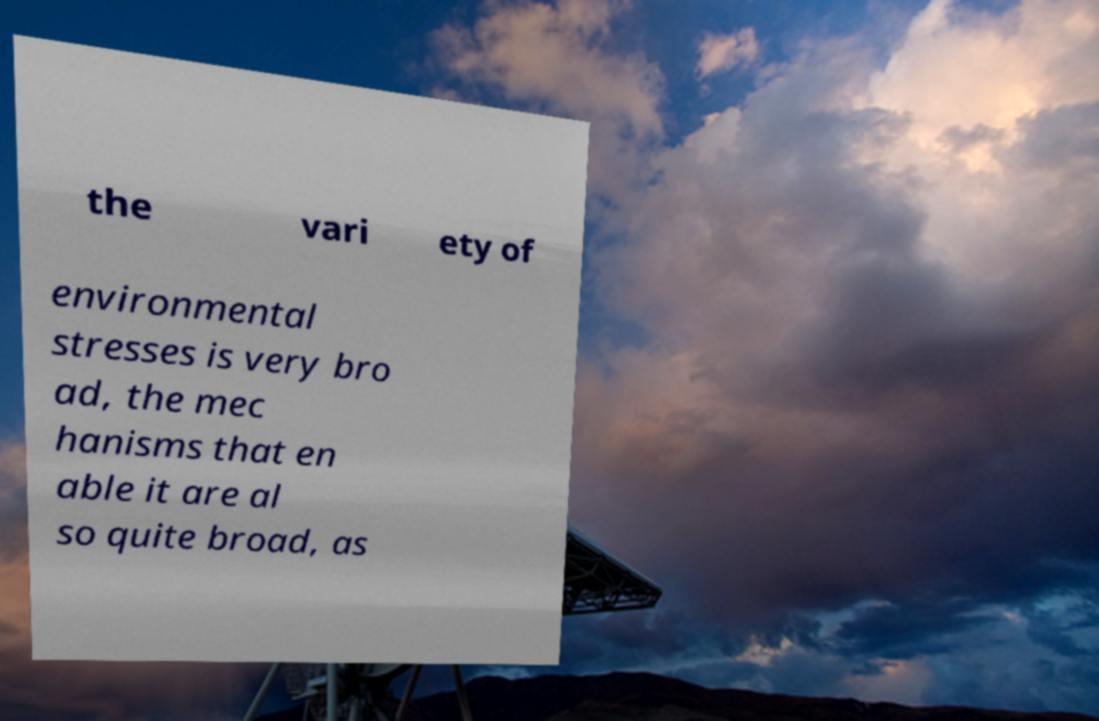For documentation purposes, I need the text within this image transcribed. Could you provide that? the vari ety of environmental stresses is very bro ad, the mec hanisms that en able it are al so quite broad, as 